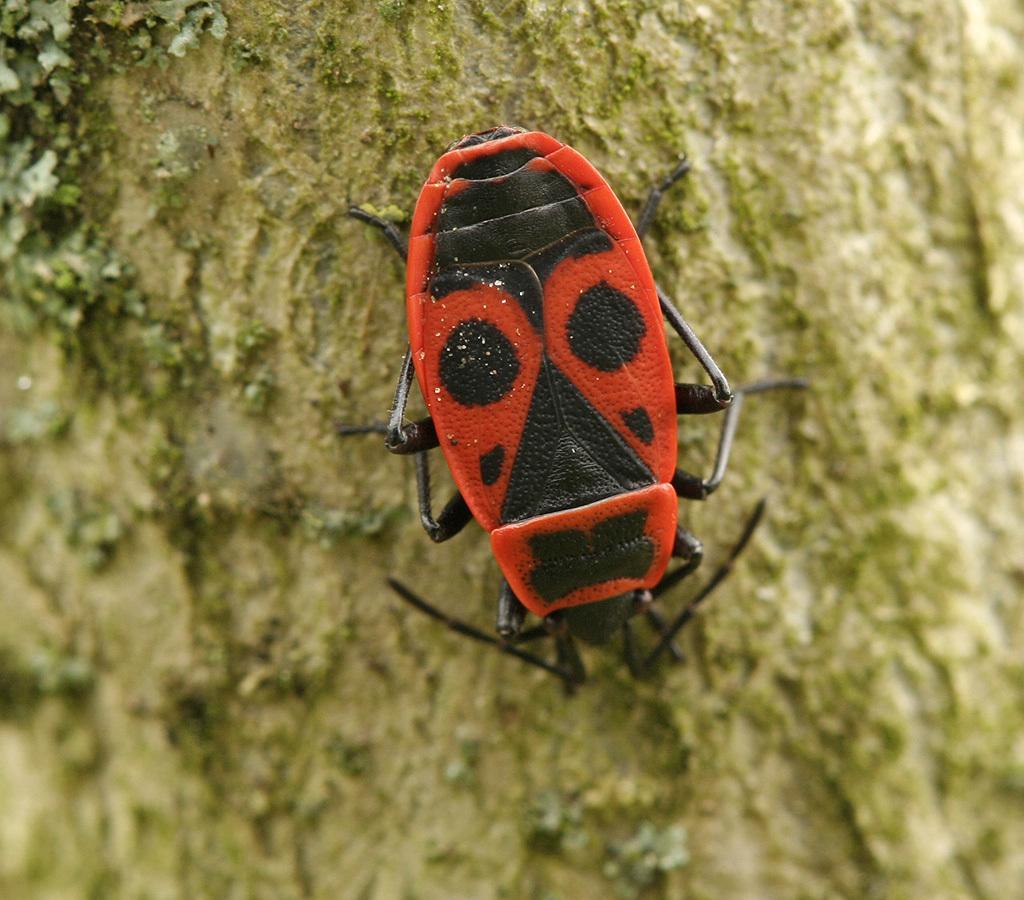How would you summarize this image in a sentence or two? In this image we can see an insect on the trunk of a tree. 